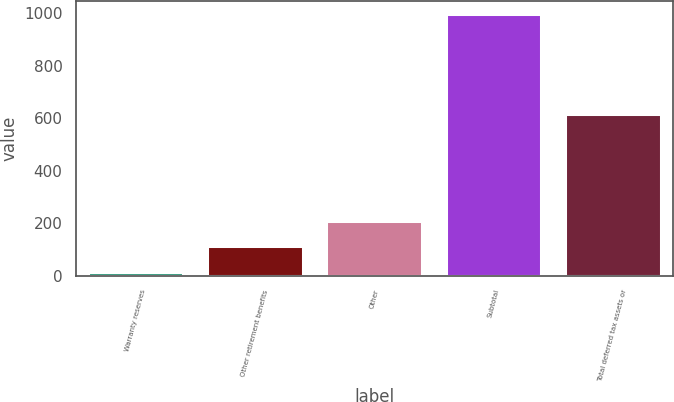Convert chart to OTSL. <chart><loc_0><loc_0><loc_500><loc_500><bar_chart><fcel>Warranty reserves<fcel>Other retirement benefits<fcel>Other<fcel>Subtotal<fcel>Total deferred tax assets or<nl><fcel>13<fcel>111.4<fcel>209.8<fcel>997<fcel>615<nl></chart> 